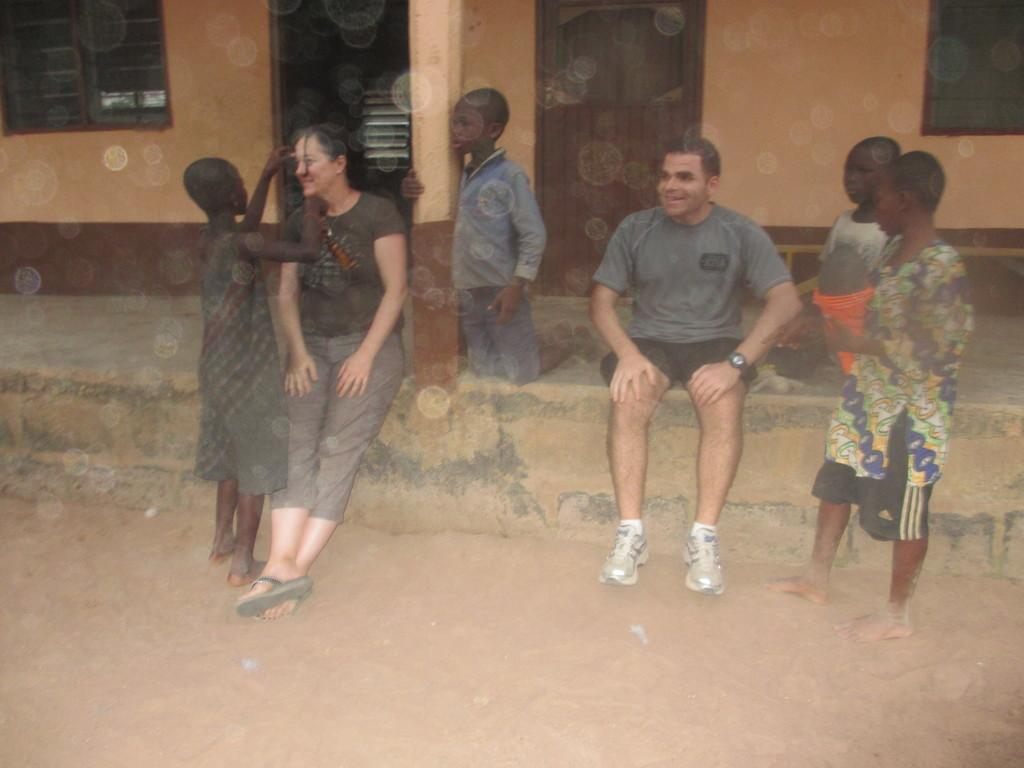Who is present in the image? There is a man and a woman in the image. What are the man and woman doing in the image? The man and woman are sitting in front of a building. Are there any children in the image? Yes, there are kids in the image. What are the kids doing in the image? The kids are standing and sitting on a wall. What type of health services are being provided in the image? There is no indication of any health services being provided in the image. Can you see any mines or mining equipment in the image? There is no mention of mines or mining equipment in the image. 